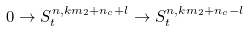<formula> <loc_0><loc_0><loc_500><loc_500>0 \rightarrow S _ { t } ^ { n , k m _ { 2 } + n _ { c } + l } \rightarrow S _ { t } ^ { n , k m _ { 2 } + n _ { c } - l }</formula> 